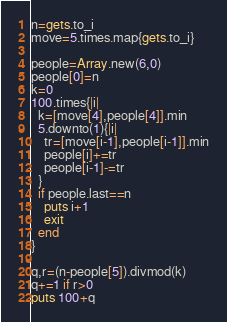Convert code to text. <code><loc_0><loc_0><loc_500><loc_500><_Ruby_>n=gets.to_i
move=5.times.map{gets.to_i}

people=Array.new(6,0)
people[0]=n
k=0
100.times{|i|
  k=[move[4],people[4]].min
  5.downto(1){|i|
    tr=[move[i-1],people[i-1]].min
    people[i]+=tr
    people[i-1]-=tr
  }
  if people.last==n
    puts i+1
    exit
  end
}

q,r=(n-people[5]).divmod(k)
q+=1 if r>0
puts 100+q</code> 